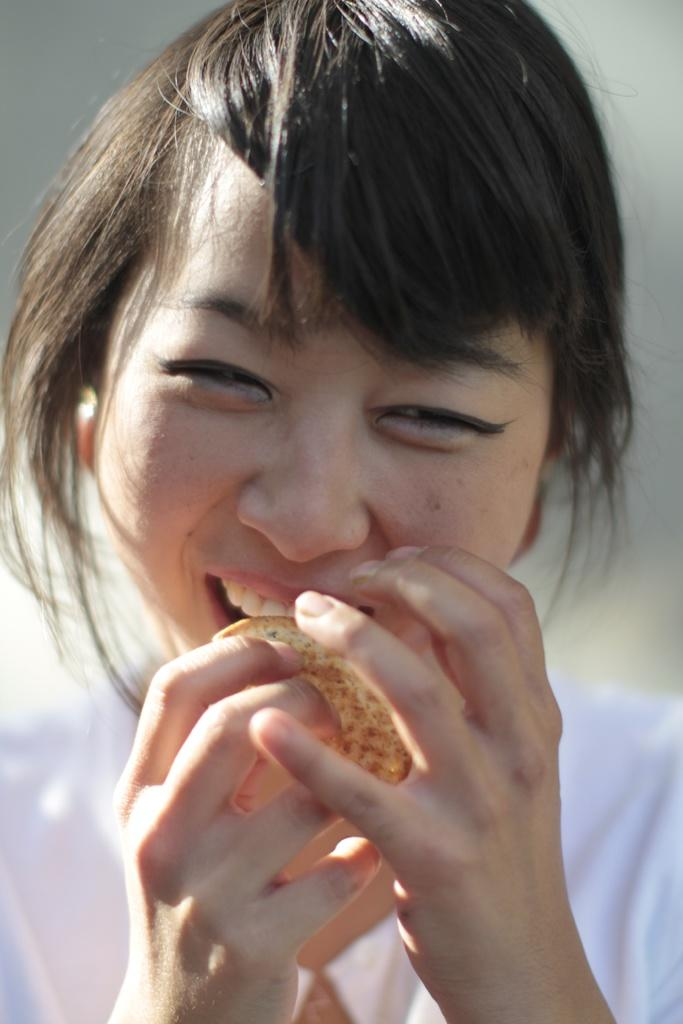Who is present in the image? There is a woman in the image. What is the woman doing in the image? The woman is smiling in the image. What is the woman holding in her hand? The woman is holding a food item in her hand. How many marbles are visible in the image? There are no marbles present in the image. Is there a person celebrating their birthday in the image? There is no indication of a birthday celebration in the image. 